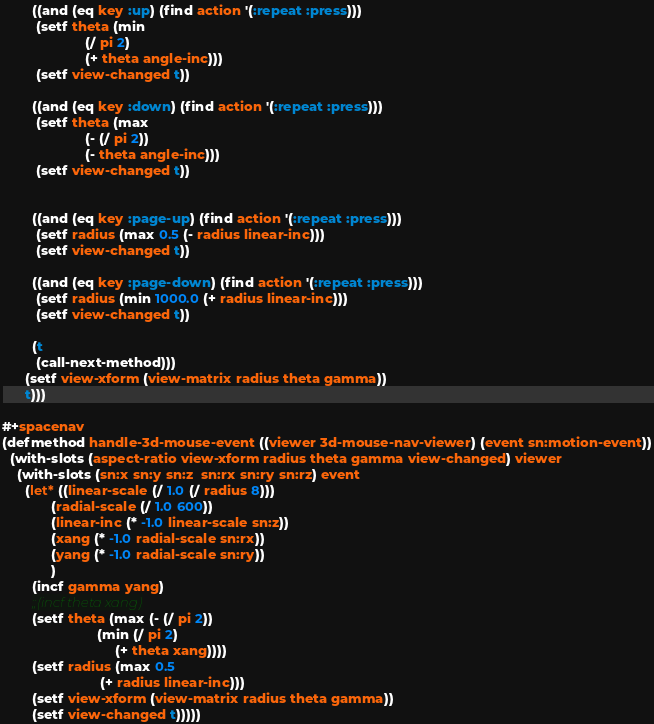<code> <loc_0><loc_0><loc_500><loc_500><_Lisp_>        ((and (eq key :up) (find action '(:repeat :press)))
         (setf theta (min
                      (/ pi 2)
                      (+ theta angle-inc)))
         (setf view-changed t))

        ((and (eq key :down) (find action '(:repeat :press)))
         (setf theta (max
                      (- (/ pi 2))
                      (- theta angle-inc)))
         (setf view-changed t))


        ((and (eq key :page-up) (find action '(:repeat :press)))
         (setf radius (max 0.5 (- radius linear-inc)))
         (setf view-changed t))

        ((and (eq key :page-down) (find action '(:repeat :press)))
         (setf radius (min 1000.0 (+ radius linear-inc)))
         (setf view-changed t))

        (t
         (call-next-method)))
      (setf view-xform (view-matrix radius theta gamma))
      t)))

#+spacenav
(defmethod handle-3d-mouse-event ((viewer 3d-mouse-nav-viewer) (event sn:motion-event))
  (with-slots (aspect-ratio view-xform radius theta gamma view-changed) viewer
    (with-slots (sn:x sn:y sn:z  sn:rx sn:ry sn:rz) event
      (let* ((linear-scale (/ 1.0 (/ radius 8)))
             (radial-scale (/ 1.0 600))
             (linear-inc (* -1.0 linear-scale sn:z))
             (xang (* -1.0 radial-scale sn:rx))
             (yang (* -1.0 radial-scale sn:ry))
             )
        (incf gamma yang)
        ;;(incf theta xang)
        (setf theta (max (- (/ pi 2))
                         (min (/ pi 2)
                              (+ theta xang))))
        (setf radius (max 0.5
                          (+ radius linear-inc)))
        (setf view-xform (view-matrix radius theta gamma))
        (setf view-changed t)))))
</code> 